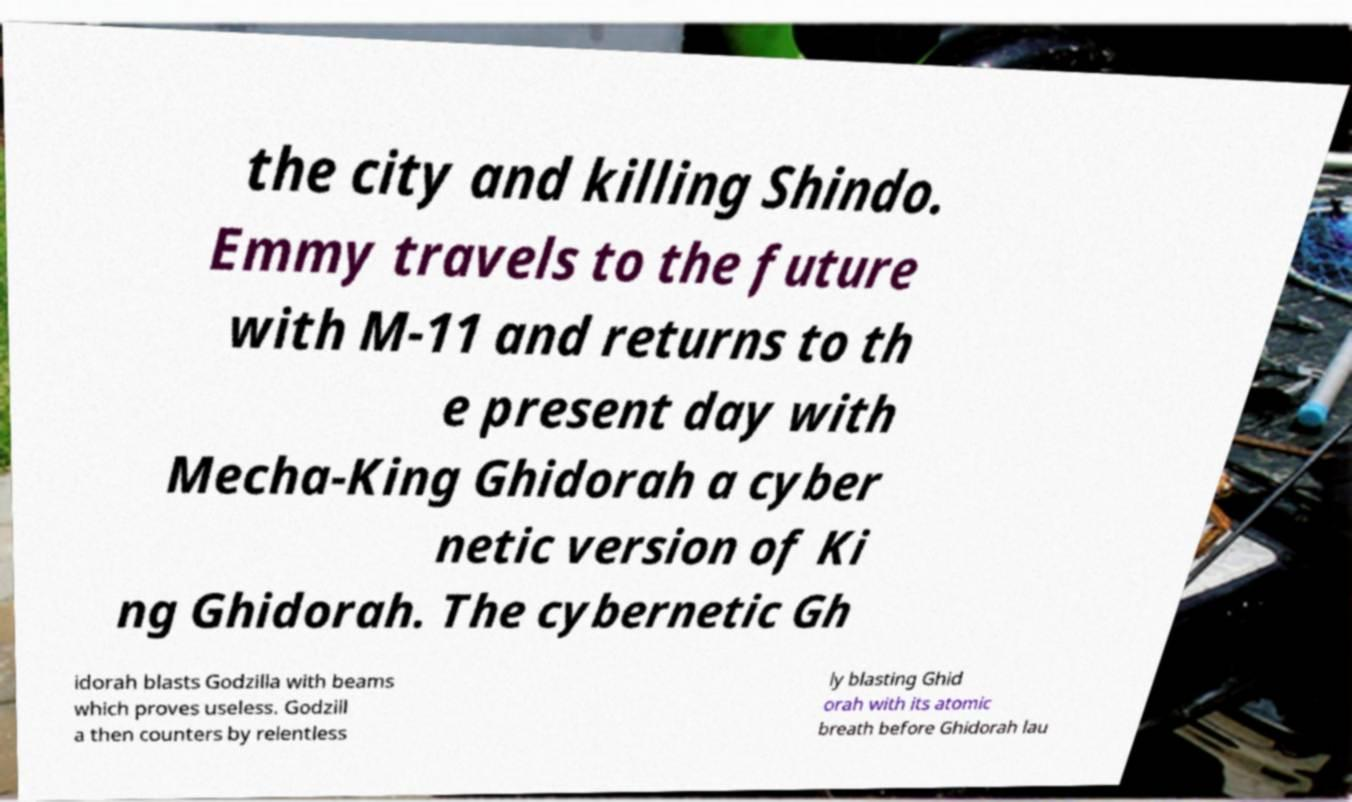What messages or text are displayed in this image? I need them in a readable, typed format. the city and killing Shindo. Emmy travels to the future with M-11 and returns to th e present day with Mecha-King Ghidorah a cyber netic version of Ki ng Ghidorah. The cybernetic Gh idorah blasts Godzilla with beams which proves useless. Godzill a then counters by relentless ly blasting Ghid orah with its atomic breath before Ghidorah lau 